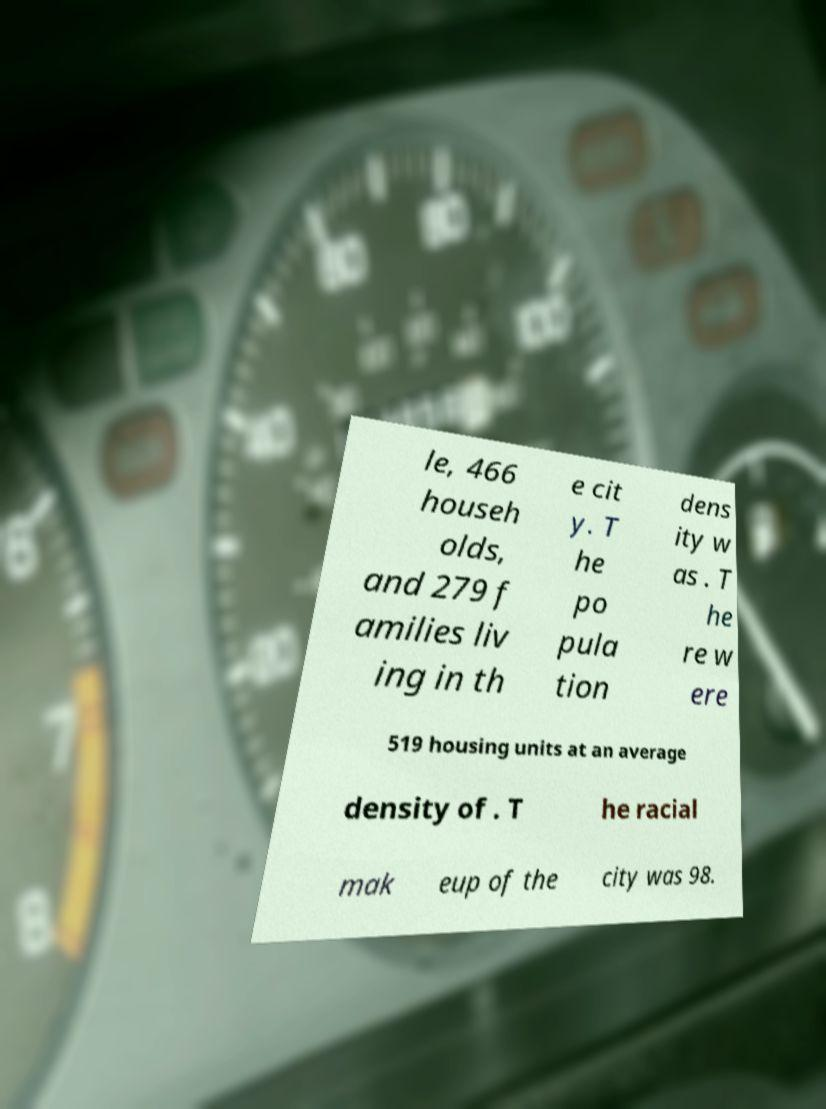Can you accurately transcribe the text from the provided image for me? le, 466 househ olds, and 279 f amilies liv ing in th e cit y. T he po pula tion dens ity w as . T he re w ere 519 housing units at an average density of . T he racial mak eup of the city was 98. 